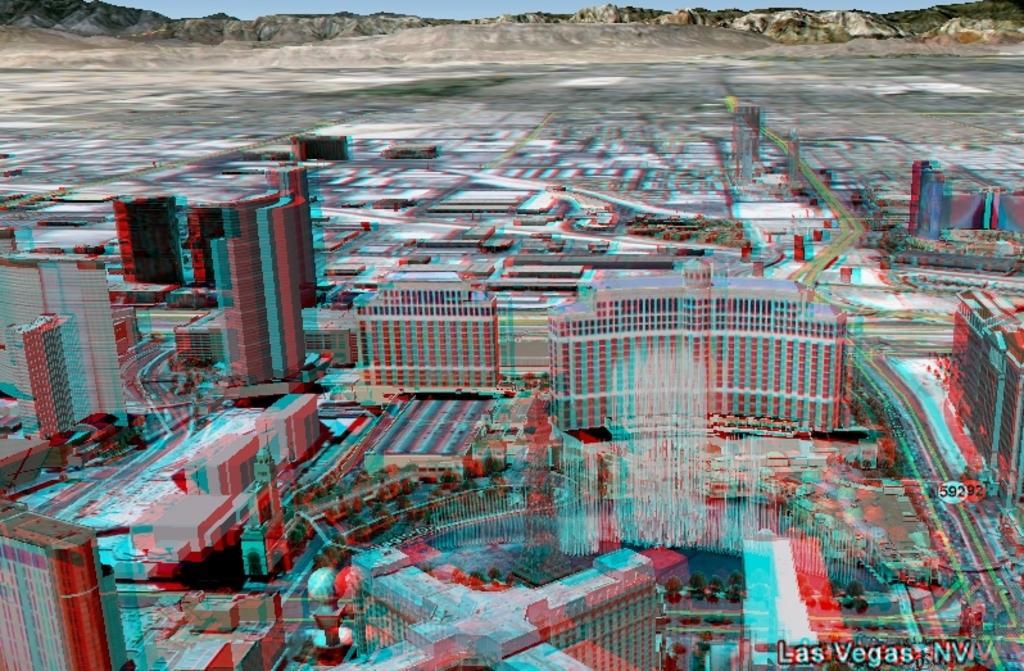Please provide a concise description of this image. In the picture we can see a photograph of Aerial view of a city with many buildings, roads with vehicles, tower buildings, grass surfaces and in the background we can see hills and behind it we can see a sky. 